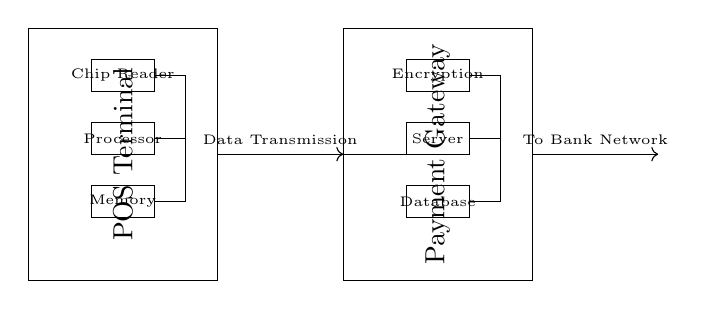What is the main purpose of the POS terminal in this circuit? The main purpose of the POS terminal is to read chip data and facilitate electronic payments. It acts as the hardware interface for the user to interact with the payment system.
Answer: Payment processing What component is responsible for data encryption? The component responsible for data encryption is labeled as "Encryption" in the circuit diagram, indicating that it secures sensitive payment information before transmission.
Answer: Encryption How many main components are in the POS terminal? The POS terminal has three main components: Chip Reader, Processor, and Memory. Each of these components plays a crucial role in processing the payment data.
Answer: Three What does the arrow labeled "Data Transmission" indicate? The arrow labeled "Data Transmission" indicates the direction and process of sending data from the POS terminal to the Payment Gateway, highlighting a critical step in the payment process.
Answer: Data flow What is the last step after data reaches the Payment Gateway? After the data reaches the Payment Gateway, the next step is sending it to the Bank Network, which is integral for completing the payment transaction with the user's bank.
Answer: To Bank Network Which component connects the POS terminal to the Payment Gateway? The direct connection line between the POS terminal and the Payment Gateway represents the pathway for data to travel between these two components.
Answer: Data Transmission 